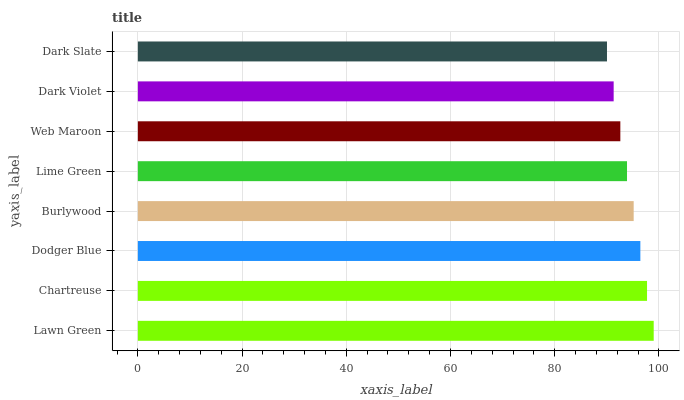Is Dark Slate the minimum?
Answer yes or no. Yes. Is Lawn Green the maximum?
Answer yes or no. Yes. Is Chartreuse the minimum?
Answer yes or no. No. Is Chartreuse the maximum?
Answer yes or no. No. Is Lawn Green greater than Chartreuse?
Answer yes or no. Yes. Is Chartreuse less than Lawn Green?
Answer yes or no. Yes. Is Chartreuse greater than Lawn Green?
Answer yes or no. No. Is Lawn Green less than Chartreuse?
Answer yes or no. No. Is Burlywood the high median?
Answer yes or no. Yes. Is Lime Green the low median?
Answer yes or no. Yes. Is Dark Violet the high median?
Answer yes or no. No. Is Burlywood the low median?
Answer yes or no. No. 